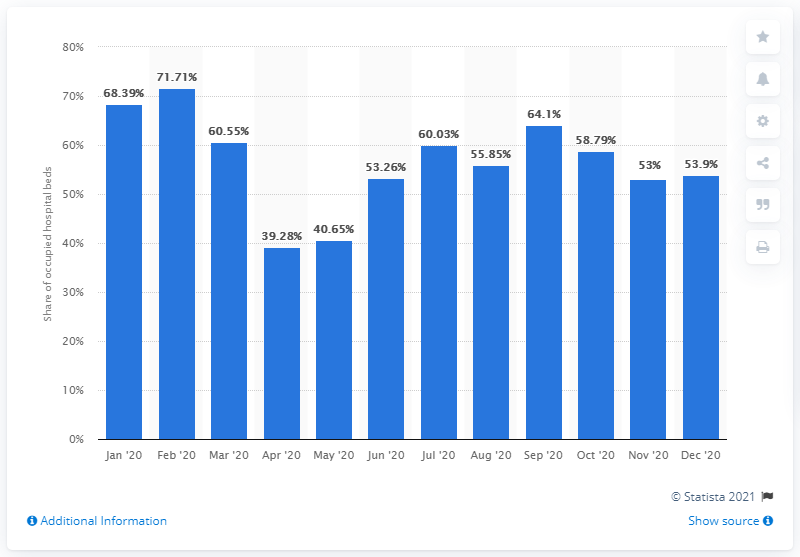Mention a couple of crucial points in this snapshot. In April of 2020, the number of occupied beds in Hungarian hospitals was 39.28%. 